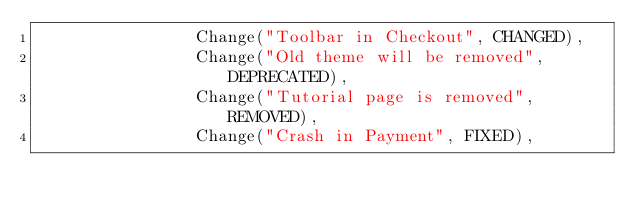Convert code to text. <code><loc_0><loc_0><loc_500><loc_500><_Kotlin_>                Change("Toolbar in Checkout", CHANGED),
                Change("Old theme will be removed", DEPRECATED),
                Change("Tutorial page is removed", REMOVED),
                Change("Crash in Payment", FIXED),</code> 